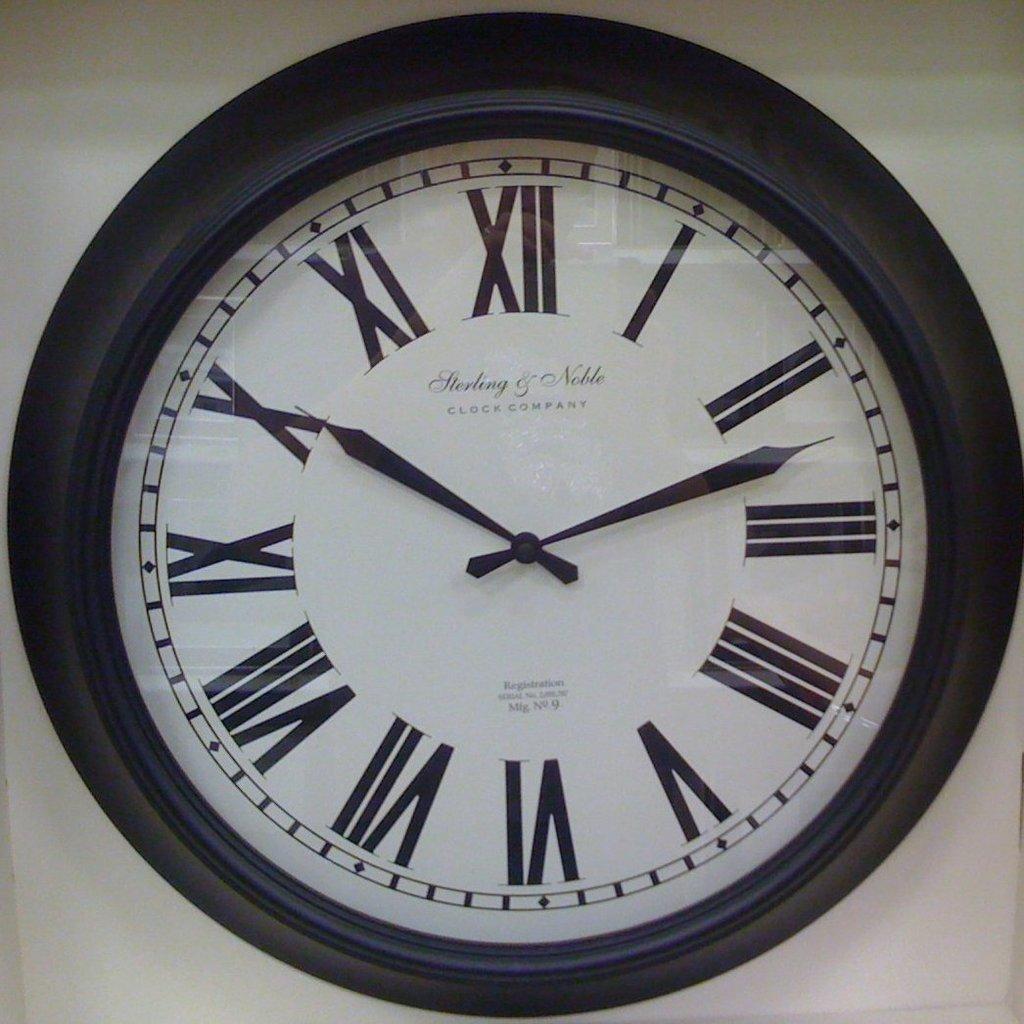What's the name of the clock company?
Give a very brief answer. Unanswerable. What time is it?
Offer a terse response. 10:12. 